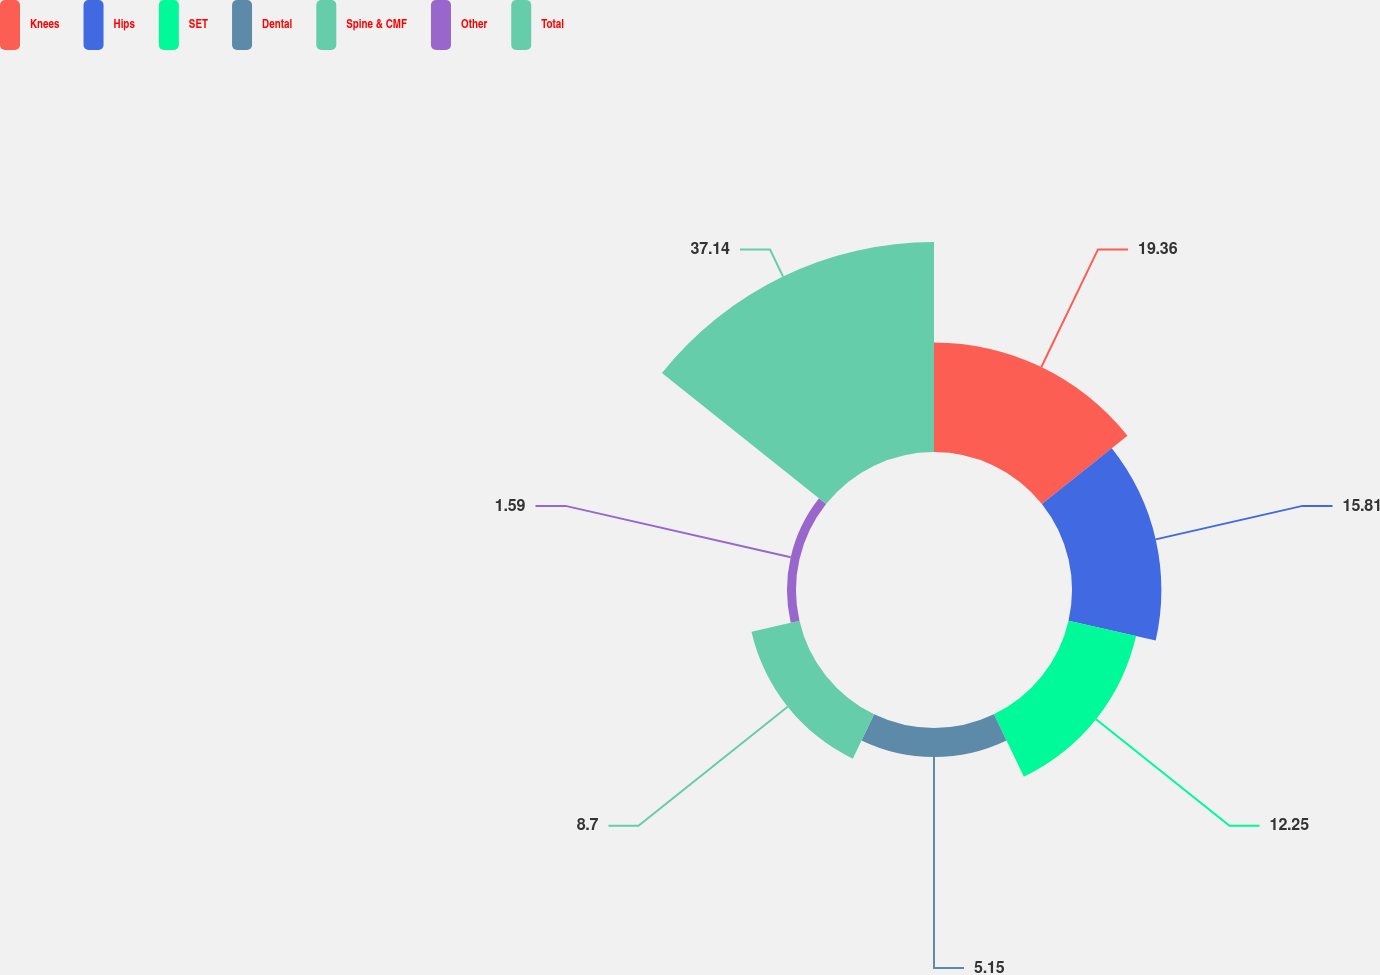Convert chart. <chart><loc_0><loc_0><loc_500><loc_500><pie_chart><fcel>Knees<fcel>Hips<fcel>SET<fcel>Dental<fcel>Spine & CMF<fcel>Other<fcel>Total<nl><fcel>19.36%<fcel>15.81%<fcel>12.25%<fcel>5.15%<fcel>8.7%<fcel>1.59%<fcel>37.14%<nl></chart> 